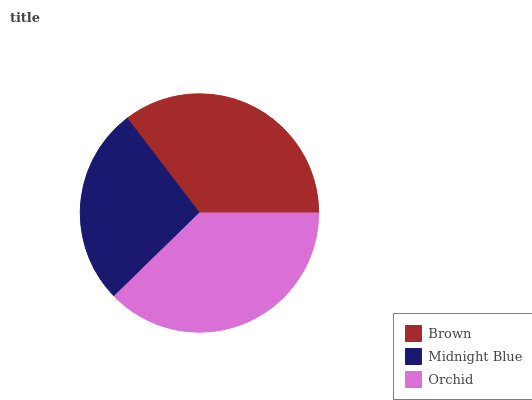Is Midnight Blue the minimum?
Answer yes or no. Yes. Is Orchid the maximum?
Answer yes or no. Yes. Is Orchid the minimum?
Answer yes or no. No. Is Midnight Blue the maximum?
Answer yes or no. No. Is Orchid greater than Midnight Blue?
Answer yes or no. Yes. Is Midnight Blue less than Orchid?
Answer yes or no. Yes. Is Midnight Blue greater than Orchid?
Answer yes or no. No. Is Orchid less than Midnight Blue?
Answer yes or no. No. Is Brown the high median?
Answer yes or no. Yes. Is Brown the low median?
Answer yes or no. Yes. Is Orchid the high median?
Answer yes or no. No. Is Midnight Blue the low median?
Answer yes or no. No. 